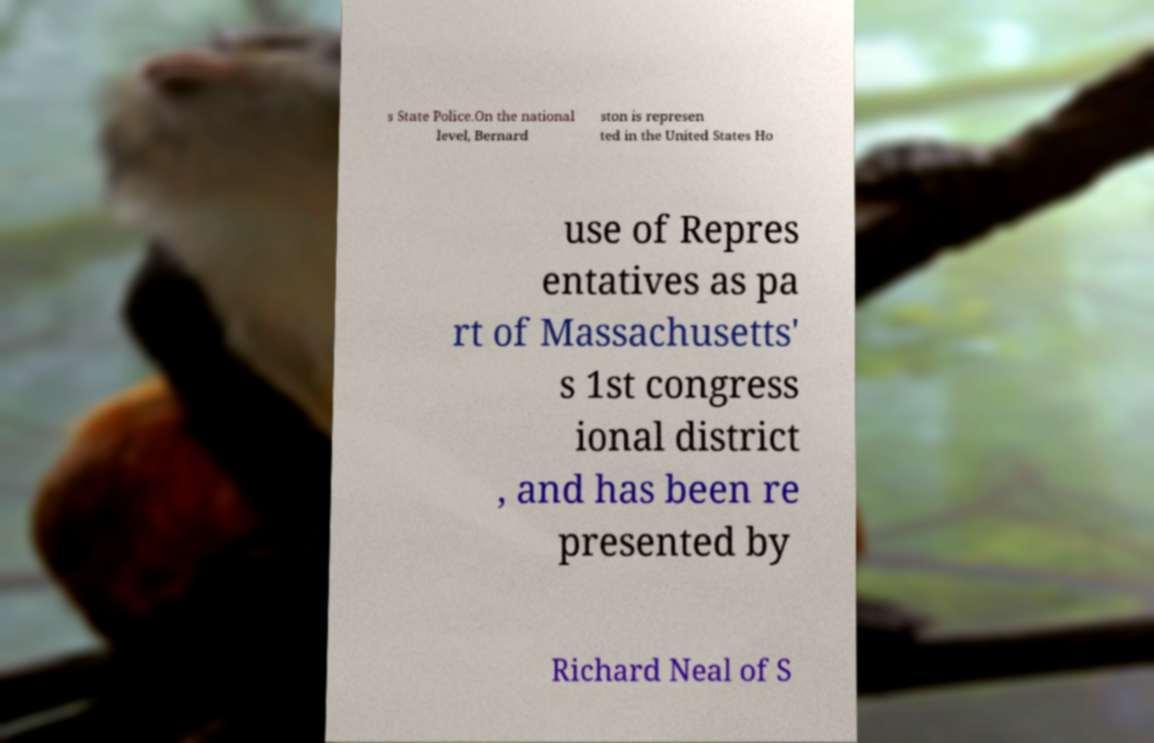Could you extract and type out the text from this image? s State Police.On the national level, Bernard ston is represen ted in the United States Ho use of Repres entatives as pa rt of Massachusetts' s 1st congress ional district , and has been re presented by Richard Neal of S 